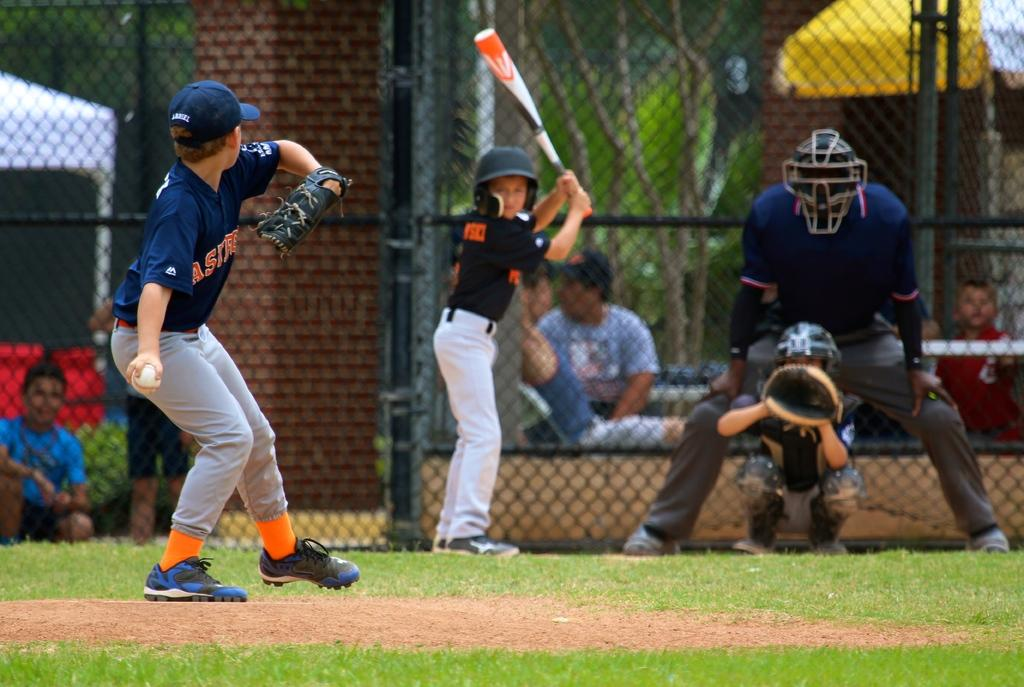<image>
Relay a brief, clear account of the picture shown. Ast are the first three letters on the bowlers top. 